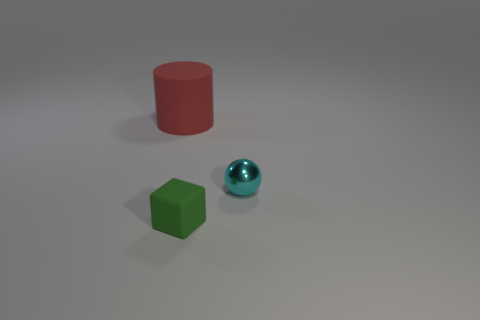What is the color of the object that is left of the small cyan metal object and behind the tiny rubber block?
Provide a short and direct response. Red. There is a thing that is on the left side of the small thing that is left of the cyan metallic object; what is it made of?
Provide a short and direct response. Rubber. Is the cube the same size as the red cylinder?
Give a very brief answer. No. How many big things are either yellow matte cylinders or red objects?
Your answer should be compact. 1. What number of cyan objects are to the right of the sphere?
Make the answer very short. 0. Are there more tiny green blocks that are in front of the big red matte thing than large green metal cylinders?
Make the answer very short. Yes. The small object that is the same material as the red cylinder is what shape?
Your answer should be compact. Cube. What color is the matte thing behind the tiny thing right of the tiny green matte block?
Keep it short and to the point. Red. Does the small metal object have the same shape as the red thing?
Give a very brief answer. No. Are there any small cyan metal balls that are left of the big red rubber object to the left of the matte object that is right of the red matte cylinder?
Your answer should be compact. No. 